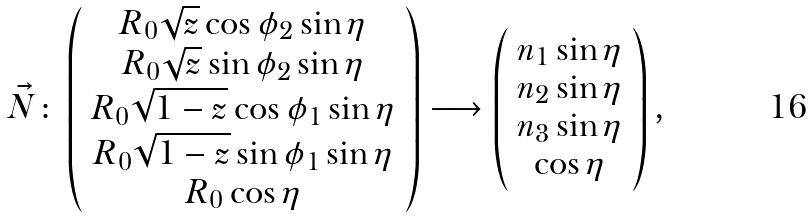Convert formula to latex. <formula><loc_0><loc_0><loc_500><loc_500>\vec { N } \colon \left ( \begin{array} { c } R _ { 0 } \sqrt { z } \cos \phi _ { 2 } \sin \eta \\ R _ { 0 } \sqrt { z } \sin \phi _ { 2 } \sin \eta \\ R _ { 0 } \sqrt { 1 - z } \cos \phi _ { 1 } \sin \eta \\ R _ { 0 } \sqrt { 1 - z } \sin \phi _ { 1 } \sin \eta \\ R _ { 0 } \cos \eta \end{array} \right ) \longrightarrow \left ( \begin{array} { c } n _ { 1 } \sin \eta \\ n _ { 2 } \sin \eta \\ n _ { 3 } \sin \eta \\ \cos \eta \end{array} \right ) ,</formula> 